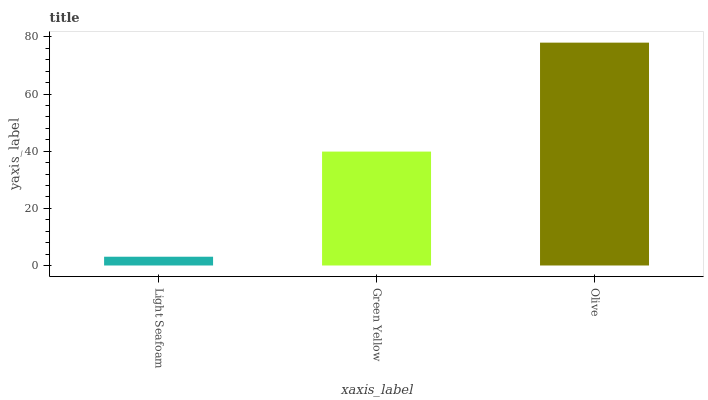Is Green Yellow the minimum?
Answer yes or no. No. Is Green Yellow the maximum?
Answer yes or no. No. Is Green Yellow greater than Light Seafoam?
Answer yes or no. Yes. Is Light Seafoam less than Green Yellow?
Answer yes or no. Yes. Is Light Seafoam greater than Green Yellow?
Answer yes or no. No. Is Green Yellow less than Light Seafoam?
Answer yes or no. No. Is Green Yellow the high median?
Answer yes or no. Yes. Is Green Yellow the low median?
Answer yes or no. Yes. Is Olive the high median?
Answer yes or no. No. Is Olive the low median?
Answer yes or no. No. 